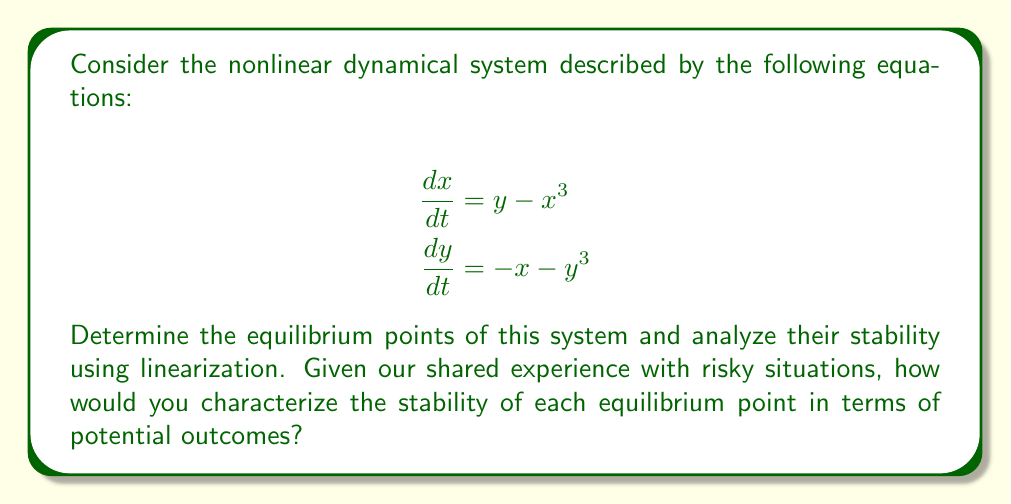Can you answer this question? 1. Find the equilibrium points:
Set $\frac{dx}{dt} = 0$ and $\frac{dy}{dt} = 0$:
$$\begin{align}
y - x^3 &= 0 \\
-x - y^3 &= 0
\end{align}$$

Solving these equations, we find that $(0,0)$ is the only equilibrium point.

2. Linearize the system around $(0,0)$:
Calculate the Jacobian matrix:
$$J = \begin{bmatrix}
\frac{\partial}{\partial x}(y-x^3) & \frac{\partial}{\partial y}(y-x^3) \\
\frac{\partial}{\partial x}(-x-y^3) & \frac{\partial}{\partial y}(-x-y^3)
\end{bmatrix}
= \begin{bmatrix}
-3x^2 & 1 \\
-1 & -3y^2
\end{bmatrix}$$

At $(0,0)$, the Jacobian becomes:
$$J_{(0,0)} = \begin{bmatrix}
0 & 1 \\
-1 & 0
\end{bmatrix}$$

3. Find the eigenvalues of $J_{(0,0)}$:
$$\det(J_{(0,0)} - \lambda I) = \begin{vmatrix}
-\lambda & 1 \\
-1 & -\lambda
\end{vmatrix} = \lambda^2 + 1 = 0$$

Solving this equation, we get $\lambda = \pm i$.

4. Analyze stability:
The eigenvalues are purely imaginary, indicating that the equilibrium point $(0,0)$ is a center. This means that trajectories near the equilibrium point will orbit around it without converging or diverging.

5. Interpretation in terms of risk:
In our shared context of dealing with risky situations, we can interpret this stability analysis as follows:
- The center equilibrium suggests that small perturbations from the equilibrium state will neither grow nor decay over time.
- This can be seen as a delicate balance, where careful management is required to maintain the current state.
- Unlike stable equilibria (which are more forgiving) or unstable equilibria (which are prone to rapid divergence), this center equilibrium requires constant vigilance and fine-tuning to prevent drift away from the desired state.
Answer: The system has one equilibrium point at $(0,0)$, which is a center (neutrally stable). 